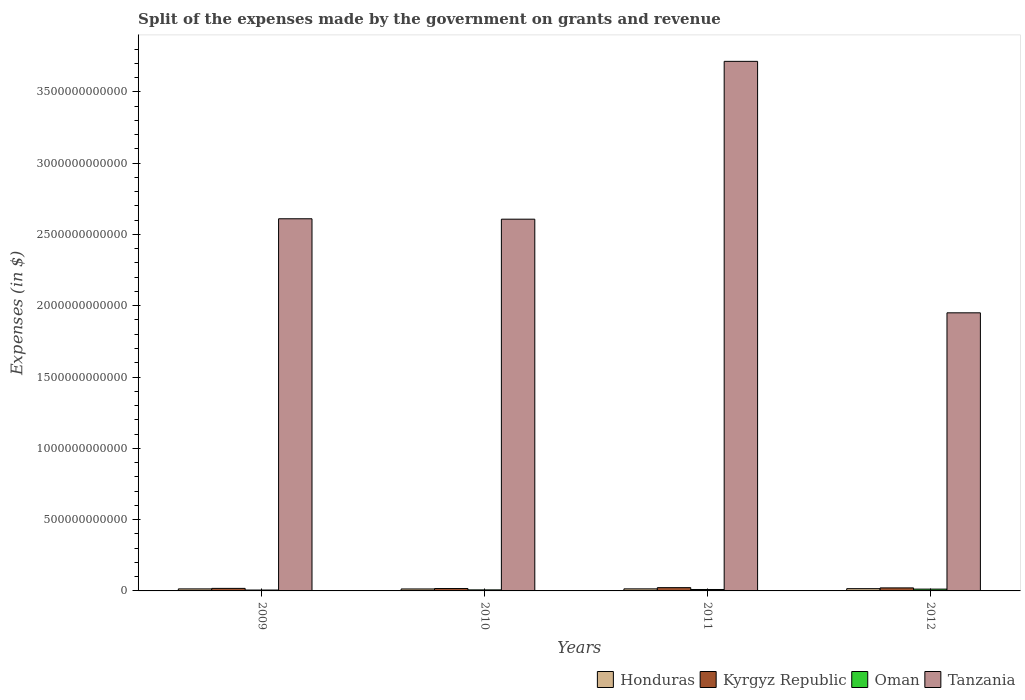How many different coloured bars are there?
Your response must be concise. 4. How many groups of bars are there?
Provide a succinct answer. 4. Are the number of bars per tick equal to the number of legend labels?
Ensure brevity in your answer.  Yes. How many bars are there on the 1st tick from the right?
Offer a terse response. 4. What is the expenses made by the government on grants and revenue in Honduras in 2009?
Provide a short and direct response. 1.41e+1. Across all years, what is the maximum expenses made by the government on grants and revenue in Honduras?
Your answer should be compact. 1.58e+1. Across all years, what is the minimum expenses made by the government on grants and revenue in Honduras?
Keep it short and to the point. 1.38e+1. In which year was the expenses made by the government on grants and revenue in Kyrgyz Republic maximum?
Your response must be concise. 2011. What is the total expenses made by the government on grants and revenue in Honduras in the graph?
Ensure brevity in your answer.  5.81e+1. What is the difference between the expenses made by the government on grants and revenue in Kyrgyz Republic in 2009 and that in 2012?
Provide a succinct answer. -3.50e+09. What is the difference between the expenses made by the government on grants and revenue in Honduras in 2011 and the expenses made by the government on grants and revenue in Tanzania in 2010?
Keep it short and to the point. -2.59e+12. What is the average expenses made by the government on grants and revenue in Kyrgyz Republic per year?
Your answer should be very brief. 1.96e+1. In the year 2011, what is the difference between the expenses made by the government on grants and revenue in Oman and expenses made by the government on grants and revenue in Tanzania?
Your answer should be very brief. -3.70e+12. What is the ratio of the expenses made by the government on grants and revenue in Kyrgyz Republic in 2010 to that in 2012?
Make the answer very short. 0.79. Is the expenses made by the government on grants and revenue in Tanzania in 2010 less than that in 2011?
Provide a short and direct response. Yes. Is the difference between the expenses made by the government on grants and revenue in Oman in 2011 and 2012 greater than the difference between the expenses made by the government on grants and revenue in Tanzania in 2011 and 2012?
Your answer should be very brief. No. What is the difference between the highest and the second highest expenses made by the government on grants and revenue in Honduras?
Your answer should be compact. 1.40e+09. What is the difference between the highest and the lowest expenses made by the government on grants and revenue in Honduras?
Give a very brief answer. 2.05e+09. Is the sum of the expenses made by the government on grants and revenue in Oman in 2009 and 2010 greater than the maximum expenses made by the government on grants and revenue in Honduras across all years?
Your answer should be compact. No. Is it the case that in every year, the sum of the expenses made by the government on grants and revenue in Tanzania and expenses made by the government on grants and revenue in Kyrgyz Republic is greater than the sum of expenses made by the government on grants and revenue in Honduras and expenses made by the government on grants and revenue in Oman?
Your response must be concise. No. What does the 3rd bar from the left in 2012 represents?
Give a very brief answer. Oman. What does the 4th bar from the right in 2011 represents?
Ensure brevity in your answer.  Honduras. Is it the case that in every year, the sum of the expenses made by the government on grants and revenue in Kyrgyz Republic and expenses made by the government on grants and revenue in Tanzania is greater than the expenses made by the government on grants and revenue in Oman?
Offer a very short reply. Yes. How many bars are there?
Make the answer very short. 16. Are all the bars in the graph horizontal?
Offer a very short reply. No. What is the difference between two consecutive major ticks on the Y-axis?
Make the answer very short. 5.00e+11. Are the values on the major ticks of Y-axis written in scientific E-notation?
Your response must be concise. No. Does the graph contain any zero values?
Give a very brief answer. No. Does the graph contain grids?
Keep it short and to the point. No. Where does the legend appear in the graph?
Offer a terse response. Bottom right. How many legend labels are there?
Keep it short and to the point. 4. How are the legend labels stacked?
Provide a short and direct response. Horizontal. What is the title of the graph?
Give a very brief answer. Split of the expenses made by the government on grants and revenue. Does "Brazil" appear as one of the legend labels in the graph?
Offer a very short reply. No. What is the label or title of the Y-axis?
Keep it short and to the point. Expenses (in $). What is the Expenses (in $) of Honduras in 2009?
Provide a short and direct response. 1.41e+1. What is the Expenses (in $) in Kyrgyz Republic in 2009?
Make the answer very short. 1.78e+1. What is the Expenses (in $) in Oman in 2009?
Your response must be concise. 6.14e+09. What is the Expenses (in $) of Tanzania in 2009?
Your answer should be very brief. 2.61e+12. What is the Expenses (in $) in Honduras in 2010?
Make the answer very short. 1.38e+1. What is the Expenses (in $) in Kyrgyz Republic in 2010?
Offer a terse response. 1.67e+1. What is the Expenses (in $) in Oman in 2010?
Provide a short and direct response. 7.31e+09. What is the Expenses (in $) of Tanzania in 2010?
Ensure brevity in your answer.  2.61e+12. What is the Expenses (in $) of Honduras in 2011?
Provide a short and direct response. 1.44e+1. What is the Expenses (in $) of Kyrgyz Republic in 2011?
Your response must be concise. 2.29e+1. What is the Expenses (in $) in Oman in 2011?
Provide a short and direct response. 9.99e+09. What is the Expenses (in $) of Tanzania in 2011?
Offer a terse response. 3.71e+12. What is the Expenses (in $) of Honduras in 2012?
Provide a succinct answer. 1.58e+1. What is the Expenses (in $) in Kyrgyz Republic in 2012?
Provide a short and direct response. 2.13e+1. What is the Expenses (in $) in Oman in 2012?
Your answer should be compact. 1.27e+1. What is the Expenses (in $) of Tanzania in 2012?
Provide a succinct answer. 1.95e+12. Across all years, what is the maximum Expenses (in $) in Honduras?
Keep it short and to the point. 1.58e+1. Across all years, what is the maximum Expenses (in $) of Kyrgyz Republic?
Offer a terse response. 2.29e+1. Across all years, what is the maximum Expenses (in $) in Oman?
Provide a short and direct response. 1.27e+1. Across all years, what is the maximum Expenses (in $) of Tanzania?
Make the answer very short. 3.71e+12. Across all years, what is the minimum Expenses (in $) of Honduras?
Provide a short and direct response. 1.38e+1. Across all years, what is the minimum Expenses (in $) of Kyrgyz Republic?
Offer a very short reply. 1.67e+1. Across all years, what is the minimum Expenses (in $) of Oman?
Offer a very short reply. 6.14e+09. Across all years, what is the minimum Expenses (in $) of Tanzania?
Offer a very short reply. 1.95e+12. What is the total Expenses (in $) in Honduras in the graph?
Your response must be concise. 5.81e+1. What is the total Expenses (in $) of Kyrgyz Republic in the graph?
Provide a succinct answer. 7.86e+1. What is the total Expenses (in $) of Oman in the graph?
Your response must be concise. 3.61e+1. What is the total Expenses (in $) of Tanzania in the graph?
Your answer should be compact. 1.09e+13. What is the difference between the Expenses (in $) in Honduras in 2009 and that in 2010?
Provide a succinct answer. 3.92e+08. What is the difference between the Expenses (in $) in Kyrgyz Republic in 2009 and that in 2010?
Offer a terse response. 1.05e+09. What is the difference between the Expenses (in $) of Oman in 2009 and that in 2010?
Provide a short and direct response. -1.17e+09. What is the difference between the Expenses (in $) in Tanzania in 2009 and that in 2010?
Make the answer very short. 2.83e+09. What is the difference between the Expenses (in $) in Honduras in 2009 and that in 2011?
Provide a short and direct response. -2.53e+08. What is the difference between the Expenses (in $) in Kyrgyz Republic in 2009 and that in 2011?
Offer a terse response. -5.15e+09. What is the difference between the Expenses (in $) of Oman in 2009 and that in 2011?
Provide a succinct answer. -3.85e+09. What is the difference between the Expenses (in $) of Tanzania in 2009 and that in 2011?
Provide a short and direct response. -1.10e+12. What is the difference between the Expenses (in $) of Honduras in 2009 and that in 2012?
Give a very brief answer. -1.66e+09. What is the difference between the Expenses (in $) of Kyrgyz Republic in 2009 and that in 2012?
Ensure brevity in your answer.  -3.50e+09. What is the difference between the Expenses (in $) in Oman in 2009 and that in 2012?
Offer a very short reply. -6.55e+09. What is the difference between the Expenses (in $) in Tanzania in 2009 and that in 2012?
Make the answer very short. 6.60e+11. What is the difference between the Expenses (in $) of Honduras in 2010 and that in 2011?
Offer a terse response. -6.45e+08. What is the difference between the Expenses (in $) of Kyrgyz Republic in 2010 and that in 2011?
Offer a terse response. -6.20e+09. What is the difference between the Expenses (in $) in Oman in 2010 and that in 2011?
Ensure brevity in your answer.  -2.68e+09. What is the difference between the Expenses (in $) of Tanzania in 2010 and that in 2011?
Provide a succinct answer. -1.11e+12. What is the difference between the Expenses (in $) of Honduras in 2010 and that in 2012?
Give a very brief answer. -2.05e+09. What is the difference between the Expenses (in $) in Kyrgyz Republic in 2010 and that in 2012?
Offer a terse response. -4.55e+09. What is the difference between the Expenses (in $) in Oman in 2010 and that in 2012?
Ensure brevity in your answer.  -5.38e+09. What is the difference between the Expenses (in $) of Tanzania in 2010 and that in 2012?
Your response must be concise. 6.57e+11. What is the difference between the Expenses (in $) of Honduras in 2011 and that in 2012?
Provide a short and direct response. -1.40e+09. What is the difference between the Expenses (in $) of Kyrgyz Republic in 2011 and that in 2012?
Your answer should be very brief. 1.64e+09. What is the difference between the Expenses (in $) of Oman in 2011 and that in 2012?
Offer a terse response. -2.70e+09. What is the difference between the Expenses (in $) of Tanzania in 2011 and that in 2012?
Give a very brief answer. 1.76e+12. What is the difference between the Expenses (in $) of Honduras in 2009 and the Expenses (in $) of Kyrgyz Republic in 2010?
Your answer should be compact. -2.55e+09. What is the difference between the Expenses (in $) of Honduras in 2009 and the Expenses (in $) of Oman in 2010?
Ensure brevity in your answer.  6.84e+09. What is the difference between the Expenses (in $) in Honduras in 2009 and the Expenses (in $) in Tanzania in 2010?
Make the answer very short. -2.59e+12. What is the difference between the Expenses (in $) in Kyrgyz Republic in 2009 and the Expenses (in $) in Oman in 2010?
Ensure brevity in your answer.  1.04e+1. What is the difference between the Expenses (in $) of Kyrgyz Republic in 2009 and the Expenses (in $) of Tanzania in 2010?
Your response must be concise. -2.59e+12. What is the difference between the Expenses (in $) in Oman in 2009 and the Expenses (in $) in Tanzania in 2010?
Provide a succinct answer. -2.60e+12. What is the difference between the Expenses (in $) in Honduras in 2009 and the Expenses (in $) in Kyrgyz Republic in 2011?
Provide a succinct answer. -8.75e+09. What is the difference between the Expenses (in $) of Honduras in 2009 and the Expenses (in $) of Oman in 2011?
Make the answer very short. 4.16e+09. What is the difference between the Expenses (in $) in Honduras in 2009 and the Expenses (in $) in Tanzania in 2011?
Give a very brief answer. -3.70e+12. What is the difference between the Expenses (in $) of Kyrgyz Republic in 2009 and the Expenses (in $) of Oman in 2011?
Provide a succinct answer. 7.76e+09. What is the difference between the Expenses (in $) of Kyrgyz Republic in 2009 and the Expenses (in $) of Tanzania in 2011?
Make the answer very short. -3.70e+12. What is the difference between the Expenses (in $) in Oman in 2009 and the Expenses (in $) in Tanzania in 2011?
Your answer should be compact. -3.71e+12. What is the difference between the Expenses (in $) of Honduras in 2009 and the Expenses (in $) of Kyrgyz Republic in 2012?
Provide a succinct answer. -7.10e+09. What is the difference between the Expenses (in $) in Honduras in 2009 and the Expenses (in $) in Oman in 2012?
Offer a very short reply. 1.46e+09. What is the difference between the Expenses (in $) of Honduras in 2009 and the Expenses (in $) of Tanzania in 2012?
Provide a succinct answer. -1.94e+12. What is the difference between the Expenses (in $) of Kyrgyz Republic in 2009 and the Expenses (in $) of Oman in 2012?
Keep it short and to the point. 5.06e+09. What is the difference between the Expenses (in $) of Kyrgyz Republic in 2009 and the Expenses (in $) of Tanzania in 2012?
Provide a short and direct response. -1.93e+12. What is the difference between the Expenses (in $) in Oman in 2009 and the Expenses (in $) in Tanzania in 2012?
Give a very brief answer. -1.94e+12. What is the difference between the Expenses (in $) of Honduras in 2010 and the Expenses (in $) of Kyrgyz Republic in 2011?
Keep it short and to the point. -9.14e+09. What is the difference between the Expenses (in $) in Honduras in 2010 and the Expenses (in $) in Oman in 2011?
Offer a very short reply. 3.77e+09. What is the difference between the Expenses (in $) in Honduras in 2010 and the Expenses (in $) in Tanzania in 2011?
Ensure brevity in your answer.  -3.70e+12. What is the difference between the Expenses (in $) of Kyrgyz Republic in 2010 and the Expenses (in $) of Oman in 2011?
Provide a short and direct response. 6.71e+09. What is the difference between the Expenses (in $) in Kyrgyz Republic in 2010 and the Expenses (in $) in Tanzania in 2011?
Offer a very short reply. -3.70e+12. What is the difference between the Expenses (in $) in Oman in 2010 and the Expenses (in $) in Tanzania in 2011?
Your response must be concise. -3.71e+12. What is the difference between the Expenses (in $) in Honduras in 2010 and the Expenses (in $) in Kyrgyz Republic in 2012?
Keep it short and to the point. -7.50e+09. What is the difference between the Expenses (in $) of Honduras in 2010 and the Expenses (in $) of Oman in 2012?
Provide a short and direct response. 1.07e+09. What is the difference between the Expenses (in $) in Honduras in 2010 and the Expenses (in $) in Tanzania in 2012?
Provide a short and direct response. -1.94e+12. What is the difference between the Expenses (in $) of Kyrgyz Republic in 2010 and the Expenses (in $) of Oman in 2012?
Your response must be concise. 4.01e+09. What is the difference between the Expenses (in $) in Kyrgyz Republic in 2010 and the Expenses (in $) in Tanzania in 2012?
Your answer should be compact. -1.93e+12. What is the difference between the Expenses (in $) of Oman in 2010 and the Expenses (in $) of Tanzania in 2012?
Make the answer very short. -1.94e+12. What is the difference between the Expenses (in $) of Honduras in 2011 and the Expenses (in $) of Kyrgyz Republic in 2012?
Provide a short and direct response. -6.85e+09. What is the difference between the Expenses (in $) in Honduras in 2011 and the Expenses (in $) in Oman in 2012?
Your answer should be compact. 1.71e+09. What is the difference between the Expenses (in $) of Honduras in 2011 and the Expenses (in $) of Tanzania in 2012?
Give a very brief answer. -1.94e+12. What is the difference between the Expenses (in $) in Kyrgyz Republic in 2011 and the Expenses (in $) in Oman in 2012?
Provide a succinct answer. 1.02e+1. What is the difference between the Expenses (in $) of Kyrgyz Republic in 2011 and the Expenses (in $) of Tanzania in 2012?
Give a very brief answer. -1.93e+12. What is the difference between the Expenses (in $) of Oman in 2011 and the Expenses (in $) of Tanzania in 2012?
Give a very brief answer. -1.94e+12. What is the average Expenses (in $) in Honduras per year?
Offer a very short reply. 1.45e+1. What is the average Expenses (in $) of Kyrgyz Republic per year?
Your answer should be compact. 1.96e+1. What is the average Expenses (in $) of Oman per year?
Your answer should be very brief. 9.03e+09. What is the average Expenses (in $) in Tanzania per year?
Provide a short and direct response. 2.72e+12. In the year 2009, what is the difference between the Expenses (in $) in Honduras and Expenses (in $) in Kyrgyz Republic?
Offer a terse response. -3.60e+09. In the year 2009, what is the difference between the Expenses (in $) of Honduras and Expenses (in $) of Oman?
Offer a very short reply. 8.01e+09. In the year 2009, what is the difference between the Expenses (in $) of Honduras and Expenses (in $) of Tanzania?
Your answer should be compact. -2.60e+12. In the year 2009, what is the difference between the Expenses (in $) in Kyrgyz Republic and Expenses (in $) in Oman?
Offer a very short reply. 1.16e+1. In the year 2009, what is the difference between the Expenses (in $) of Kyrgyz Republic and Expenses (in $) of Tanzania?
Make the answer very short. -2.59e+12. In the year 2009, what is the difference between the Expenses (in $) in Oman and Expenses (in $) in Tanzania?
Give a very brief answer. -2.60e+12. In the year 2010, what is the difference between the Expenses (in $) in Honduras and Expenses (in $) in Kyrgyz Republic?
Give a very brief answer. -2.95e+09. In the year 2010, what is the difference between the Expenses (in $) in Honduras and Expenses (in $) in Oman?
Your answer should be compact. 6.45e+09. In the year 2010, what is the difference between the Expenses (in $) in Honduras and Expenses (in $) in Tanzania?
Keep it short and to the point. -2.59e+12. In the year 2010, what is the difference between the Expenses (in $) in Kyrgyz Republic and Expenses (in $) in Oman?
Offer a very short reply. 9.40e+09. In the year 2010, what is the difference between the Expenses (in $) in Kyrgyz Republic and Expenses (in $) in Tanzania?
Provide a succinct answer. -2.59e+12. In the year 2010, what is the difference between the Expenses (in $) of Oman and Expenses (in $) of Tanzania?
Make the answer very short. -2.60e+12. In the year 2011, what is the difference between the Expenses (in $) of Honduras and Expenses (in $) of Kyrgyz Republic?
Give a very brief answer. -8.50e+09. In the year 2011, what is the difference between the Expenses (in $) in Honduras and Expenses (in $) in Oman?
Provide a succinct answer. 4.41e+09. In the year 2011, what is the difference between the Expenses (in $) of Honduras and Expenses (in $) of Tanzania?
Your answer should be compact. -3.70e+12. In the year 2011, what is the difference between the Expenses (in $) in Kyrgyz Republic and Expenses (in $) in Oman?
Your response must be concise. 1.29e+1. In the year 2011, what is the difference between the Expenses (in $) of Kyrgyz Republic and Expenses (in $) of Tanzania?
Provide a succinct answer. -3.69e+12. In the year 2011, what is the difference between the Expenses (in $) in Oman and Expenses (in $) in Tanzania?
Your answer should be compact. -3.70e+12. In the year 2012, what is the difference between the Expenses (in $) of Honduras and Expenses (in $) of Kyrgyz Republic?
Offer a terse response. -5.45e+09. In the year 2012, what is the difference between the Expenses (in $) of Honduras and Expenses (in $) of Oman?
Offer a terse response. 3.12e+09. In the year 2012, what is the difference between the Expenses (in $) in Honduras and Expenses (in $) in Tanzania?
Offer a very short reply. -1.93e+12. In the year 2012, what is the difference between the Expenses (in $) in Kyrgyz Republic and Expenses (in $) in Oman?
Keep it short and to the point. 8.56e+09. In the year 2012, what is the difference between the Expenses (in $) in Kyrgyz Republic and Expenses (in $) in Tanzania?
Ensure brevity in your answer.  -1.93e+12. In the year 2012, what is the difference between the Expenses (in $) in Oman and Expenses (in $) in Tanzania?
Ensure brevity in your answer.  -1.94e+12. What is the ratio of the Expenses (in $) of Honduras in 2009 to that in 2010?
Make the answer very short. 1.03. What is the ratio of the Expenses (in $) in Kyrgyz Republic in 2009 to that in 2010?
Your answer should be compact. 1.06. What is the ratio of the Expenses (in $) of Oman in 2009 to that in 2010?
Provide a short and direct response. 0.84. What is the ratio of the Expenses (in $) of Tanzania in 2009 to that in 2010?
Ensure brevity in your answer.  1. What is the ratio of the Expenses (in $) in Honduras in 2009 to that in 2011?
Make the answer very short. 0.98. What is the ratio of the Expenses (in $) of Kyrgyz Republic in 2009 to that in 2011?
Provide a short and direct response. 0.78. What is the ratio of the Expenses (in $) of Oman in 2009 to that in 2011?
Provide a succinct answer. 0.61. What is the ratio of the Expenses (in $) in Tanzania in 2009 to that in 2011?
Your response must be concise. 0.7. What is the ratio of the Expenses (in $) in Honduras in 2009 to that in 2012?
Offer a terse response. 0.9. What is the ratio of the Expenses (in $) in Kyrgyz Republic in 2009 to that in 2012?
Your answer should be compact. 0.84. What is the ratio of the Expenses (in $) in Oman in 2009 to that in 2012?
Your answer should be very brief. 0.48. What is the ratio of the Expenses (in $) of Tanzania in 2009 to that in 2012?
Ensure brevity in your answer.  1.34. What is the ratio of the Expenses (in $) in Honduras in 2010 to that in 2011?
Provide a short and direct response. 0.96. What is the ratio of the Expenses (in $) of Kyrgyz Republic in 2010 to that in 2011?
Provide a short and direct response. 0.73. What is the ratio of the Expenses (in $) in Oman in 2010 to that in 2011?
Your answer should be compact. 0.73. What is the ratio of the Expenses (in $) in Tanzania in 2010 to that in 2011?
Provide a short and direct response. 0.7. What is the ratio of the Expenses (in $) in Honduras in 2010 to that in 2012?
Keep it short and to the point. 0.87. What is the ratio of the Expenses (in $) in Kyrgyz Republic in 2010 to that in 2012?
Your response must be concise. 0.79. What is the ratio of the Expenses (in $) in Oman in 2010 to that in 2012?
Give a very brief answer. 0.58. What is the ratio of the Expenses (in $) of Tanzania in 2010 to that in 2012?
Provide a succinct answer. 1.34. What is the ratio of the Expenses (in $) of Honduras in 2011 to that in 2012?
Make the answer very short. 0.91. What is the ratio of the Expenses (in $) of Kyrgyz Republic in 2011 to that in 2012?
Offer a very short reply. 1.08. What is the ratio of the Expenses (in $) of Oman in 2011 to that in 2012?
Provide a short and direct response. 0.79. What is the ratio of the Expenses (in $) of Tanzania in 2011 to that in 2012?
Provide a short and direct response. 1.9. What is the difference between the highest and the second highest Expenses (in $) in Honduras?
Provide a succinct answer. 1.40e+09. What is the difference between the highest and the second highest Expenses (in $) of Kyrgyz Republic?
Provide a short and direct response. 1.64e+09. What is the difference between the highest and the second highest Expenses (in $) of Oman?
Ensure brevity in your answer.  2.70e+09. What is the difference between the highest and the second highest Expenses (in $) of Tanzania?
Provide a succinct answer. 1.10e+12. What is the difference between the highest and the lowest Expenses (in $) in Honduras?
Your answer should be very brief. 2.05e+09. What is the difference between the highest and the lowest Expenses (in $) of Kyrgyz Republic?
Provide a succinct answer. 6.20e+09. What is the difference between the highest and the lowest Expenses (in $) of Oman?
Give a very brief answer. 6.55e+09. What is the difference between the highest and the lowest Expenses (in $) of Tanzania?
Offer a terse response. 1.76e+12. 